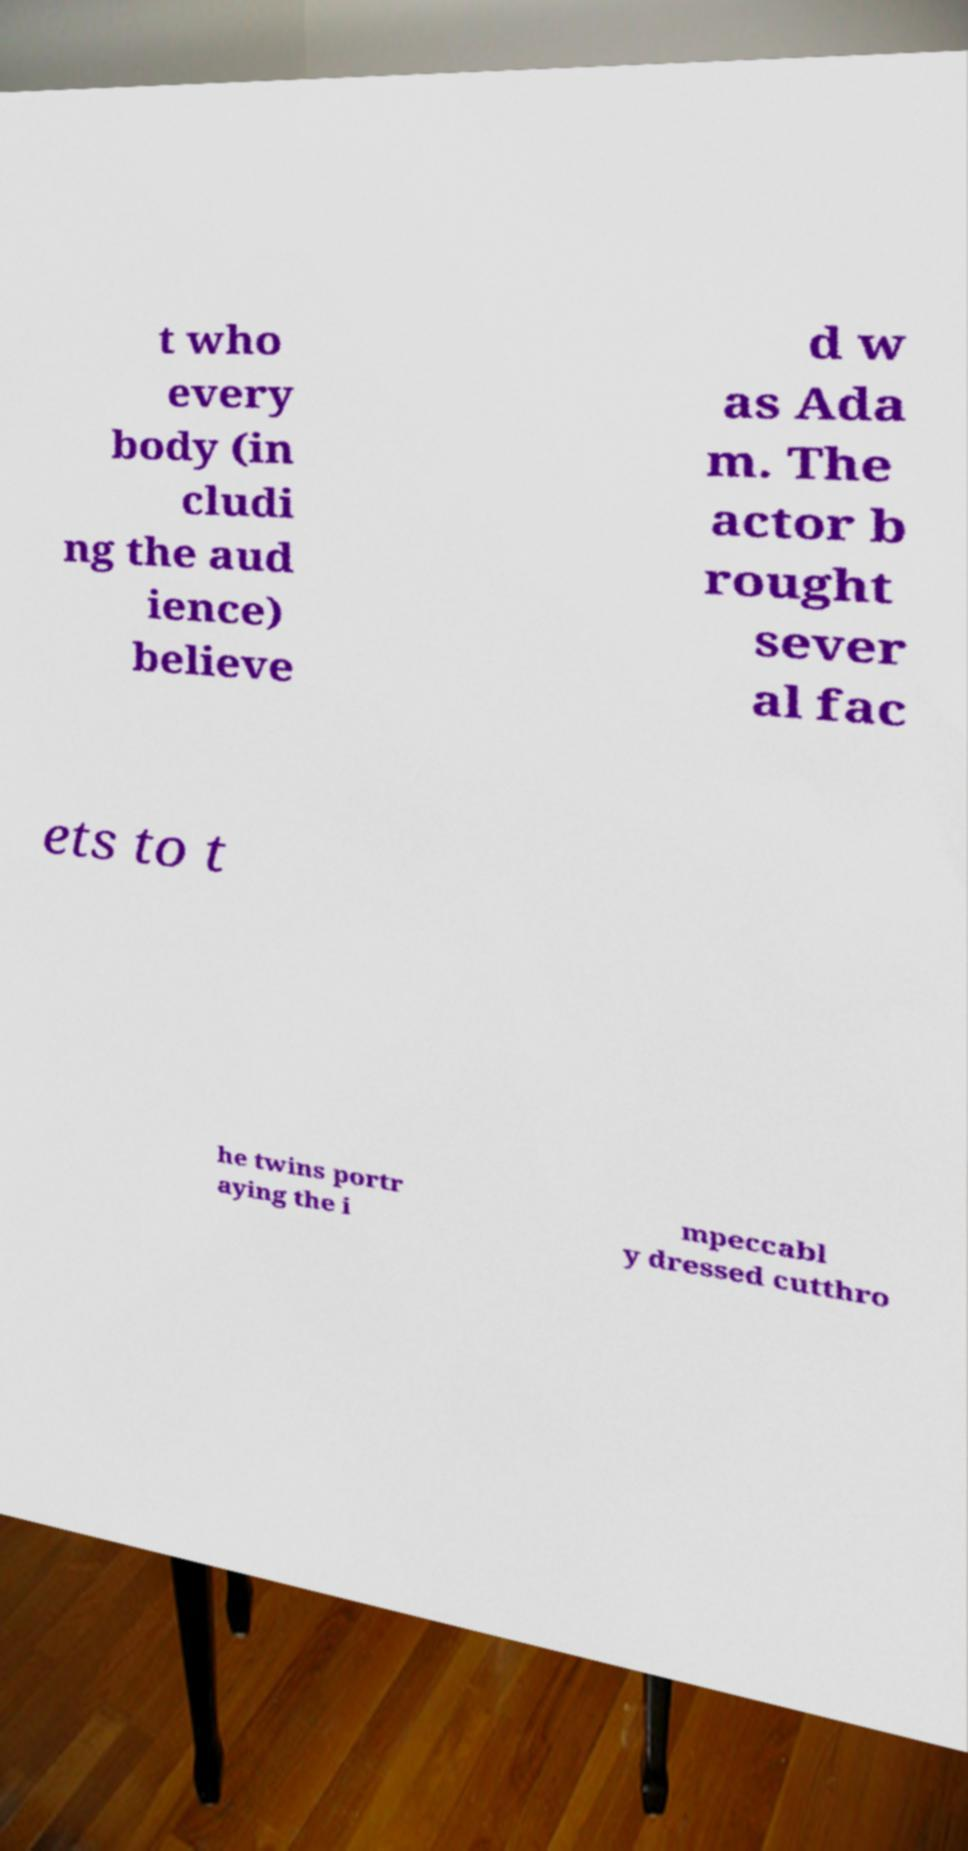Please identify and transcribe the text found in this image. t who every body (in cludi ng the aud ience) believe d w as Ada m. The actor b rought sever al fac ets to t he twins portr aying the i mpeccabl y dressed cutthro 